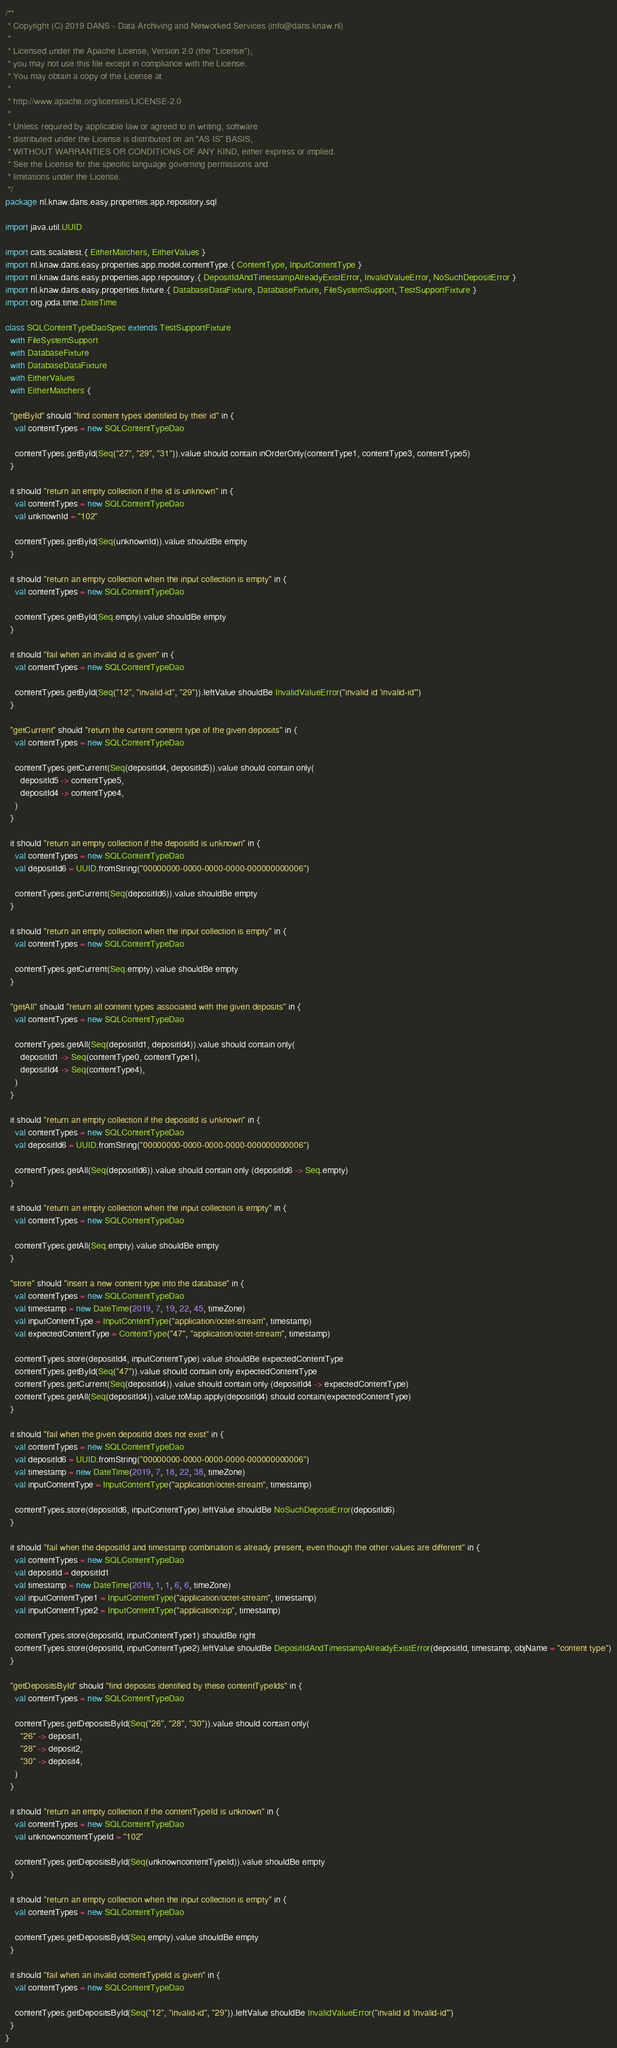Convert code to text. <code><loc_0><loc_0><loc_500><loc_500><_Scala_>/**
 * Copyright (C) 2019 DANS - Data Archiving and Networked Services (info@dans.knaw.nl)
 *
 * Licensed under the Apache License, Version 2.0 (the "License");
 * you may not use this file except in compliance with the License.
 * You may obtain a copy of the License at
 *
 * http://www.apache.org/licenses/LICENSE-2.0
 *
 * Unless required by applicable law or agreed to in writing, software
 * distributed under the License is distributed on an "AS IS" BASIS,
 * WITHOUT WARRANTIES OR CONDITIONS OF ANY KIND, either express or implied.
 * See the License for the specific language governing permissions and
 * limitations under the License.
 */
package nl.knaw.dans.easy.properties.app.repository.sql

import java.util.UUID

import cats.scalatest.{ EitherMatchers, EitherValues }
import nl.knaw.dans.easy.properties.app.model.contentType.{ ContentType, InputContentType }
import nl.knaw.dans.easy.properties.app.repository.{ DepositIdAndTimestampAlreadyExistError, InvalidValueError, NoSuchDepositError }
import nl.knaw.dans.easy.properties.fixture.{ DatabaseDataFixture, DatabaseFixture, FileSystemSupport, TestSupportFixture }
import org.joda.time.DateTime

class SQLContentTypeDaoSpec extends TestSupportFixture
  with FileSystemSupport
  with DatabaseFixture
  with DatabaseDataFixture
  with EitherValues
  with EitherMatchers {

  "getById" should "find content types identified by their id" in {
    val contentTypes = new SQLContentTypeDao

    contentTypes.getById(Seq("27", "29", "31")).value should contain inOrderOnly(contentType1, contentType3, contentType5)
  }

  it should "return an empty collection if the id is unknown" in {
    val contentTypes = new SQLContentTypeDao
    val unknownId = "102"

    contentTypes.getById(Seq(unknownId)).value shouldBe empty
  }

  it should "return an empty collection when the input collection is empty" in {
    val contentTypes = new SQLContentTypeDao

    contentTypes.getById(Seq.empty).value shouldBe empty
  }

  it should "fail when an invalid id is given" in {
    val contentTypes = new SQLContentTypeDao

    contentTypes.getById(Seq("12", "invalid-id", "29")).leftValue shouldBe InvalidValueError("invalid id 'invalid-id'")
  }

  "getCurrent" should "return the current content type of the given deposits" in {
    val contentTypes = new SQLContentTypeDao

    contentTypes.getCurrent(Seq(depositId4, depositId5)).value should contain only(
      depositId5 -> contentType5,
      depositId4 -> contentType4,
    )
  }

  it should "return an empty collection if the depositId is unknown" in {
    val contentTypes = new SQLContentTypeDao
    val depositId6 = UUID.fromString("00000000-0000-0000-0000-000000000006")

    contentTypes.getCurrent(Seq(depositId6)).value shouldBe empty
  }

  it should "return an empty collection when the input collection is empty" in {
    val contentTypes = new SQLContentTypeDao

    contentTypes.getCurrent(Seq.empty).value shouldBe empty
  }

  "getAll" should "return all content types associated with the given deposits" in {
    val contentTypes = new SQLContentTypeDao

    contentTypes.getAll(Seq(depositId1, depositId4)).value should contain only(
      depositId1 -> Seq(contentType0, contentType1),
      depositId4 -> Seq(contentType4),
    )
  }

  it should "return an empty collection if the depositId is unknown" in {
    val contentTypes = new SQLContentTypeDao
    val depositId6 = UUID.fromString("00000000-0000-0000-0000-000000000006")

    contentTypes.getAll(Seq(depositId6)).value should contain only (depositId6 -> Seq.empty)
  }

  it should "return an empty collection when the input collection is empty" in {
    val contentTypes = new SQLContentTypeDao

    contentTypes.getAll(Seq.empty).value shouldBe empty
  }

  "store" should "insert a new content type into the database" in {
    val contentTypes = new SQLContentTypeDao
    val timestamp = new DateTime(2019, 7, 19, 22, 45, timeZone)
    val inputContentType = InputContentType("application/octet-stream", timestamp)
    val expectedContentType = ContentType("47", "application/octet-stream", timestamp)

    contentTypes.store(depositId4, inputContentType).value shouldBe expectedContentType
    contentTypes.getById(Seq("47")).value should contain only expectedContentType
    contentTypes.getCurrent(Seq(depositId4)).value should contain only (depositId4 -> expectedContentType)
    contentTypes.getAll(Seq(depositId4)).value.toMap.apply(depositId4) should contain(expectedContentType)
  }

  it should "fail when the given depositId does not exist" in {
    val contentTypes = new SQLContentTypeDao
    val depositId6 = UUID.fromString("00000000-0000-0000-0000-000000000006")
    val timestamp = new DateTime(2019, 7, 18, 22, 38, timeZone)
    val inputContentType = InputContentType("application/octet-stream", timestamp)

    contentTypes.store(depositId6, inputContentType).leftValue shouldBe NoSuchDepositError(depositId6)
  }

  it should "fail when the depositId and timestamp combination is already present, even though the other values are different" in {
    val contentTypes = new SQLContentTypeDao
    val depositId = depositId1
    val timestamp = new DateTime(2019, 1, 1, 6, 6, timeZone)
    val inputContentType1 = InputContentType("application/octet-stream", timestamp)
    val inputContentType2 = InputContentType("application/zip", timestamp)

    contentTypes.store(depositId, inputContentType1) shouldBe right
    contentTypes.store(depositId, inputContentType2).leftValue shouldBe DepositIdAndTimestampAlreadyExistError(depositId, timestamp, objName = "content type")
  }

  "getDepositsById" should "find deposits identified by these contentTypeIds" in {
    val contentTypes = new SQLContentTypeDao

    contentTypes.getDepositsById(Seq("26", "28", "30")).value should contain only(
      "26" -> deposit1,
      "28" -> deposit2,
      "30" -> deposit4,
    )
  }

  it should "return an empty collection if the contentTypeId is unknown" in {
    val contentTypes = new SQLContentTypeDao
    val unknowncontentTypeId = "102"

    contentTypes.getDepositsById(Seq(unknowncontentTypeId)).value shouldBe empty
  }

  it should "return an empty collection when the input collection is empty" in {
    val contentTypes = new SQLContentTypeDao

    contentTypes.getDepositsById(Seq.empty).value shouldBe empty
  }

  it should "fail when an invalid contentTypeId is given" in {
    val contentTypes = new SQLContentTypeDao

    contentTypes.getDepositsById(Seq("12", "invalid-id", "29")).leftValue shouldBe InvalidValueError("invalid id 'invalid-id'")
  }
}
</code> 